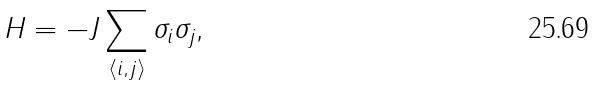<formula> <loc_0><loc_0><loc_500><loc_500>H = - J \sum _ { \left \langle i , j \right \rangle } \sigma _ { i } \sigma _ { j } \text {,}</formula> 